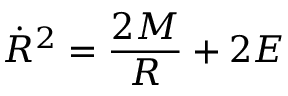Convert formula to latex. <formula><loc_0><loc_0><loc_500><loc_500>{ \dot { R } } ^ { 2 } = { \frac { 2 M } { R } } + 2 E</formula> 